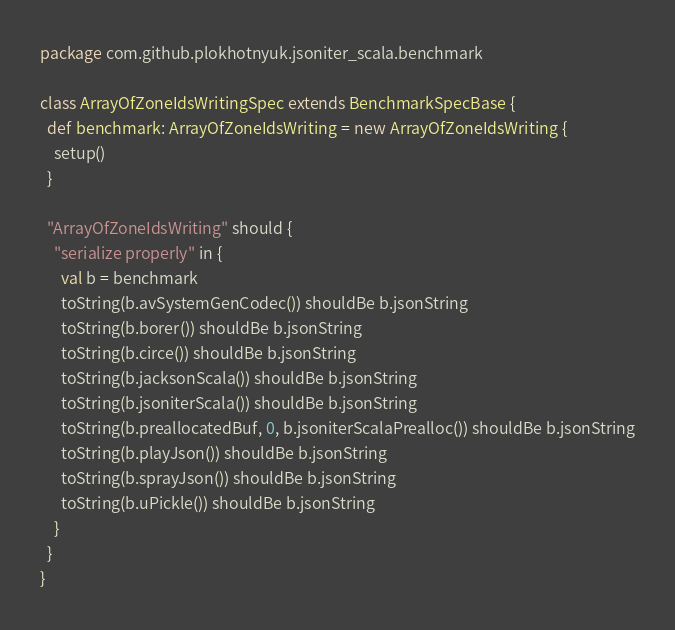<code> <loc_0><loc_0><loc_500><loc_500><_Scala_>package com.github.plokhotnyuk.jsoniter_scala.benchmark

class ArrayOfZoneIdsWritingSpec extends BenchmarkSpecBase {
  def benchmark: ArrayOfZoneIdsWriting = new ArrayOfZoneIdsWriting {
    setup()
  }
  
  "ArrayOfZoneIdsWriting" should {
    "serialize properly" in {
      val b = benchmark
      toString(b.avSystemGenCodec()) shouldBe b.jsonString
      toString(b.borer()) shouldBe b.jsonString
      toString(b.circe()) shouldBe b.jsonString
      toString(b.jacksonScala()) shouldBe b.jsonString
      toString(b.jsoniterScala()) shouldBe b.jsonString
      toString(b.preallocatedBuf, 0, b.jsoniterScalaPrealloc()) shouldBe b.jsonString
      toString(b.playJson()) shouldBe b.jsonString
      toString(b.sprayJson()) shouldBe b.jsonString
      toString(b.uPickle()) shouldBe b.jsonString
    }
  }
}</code> 